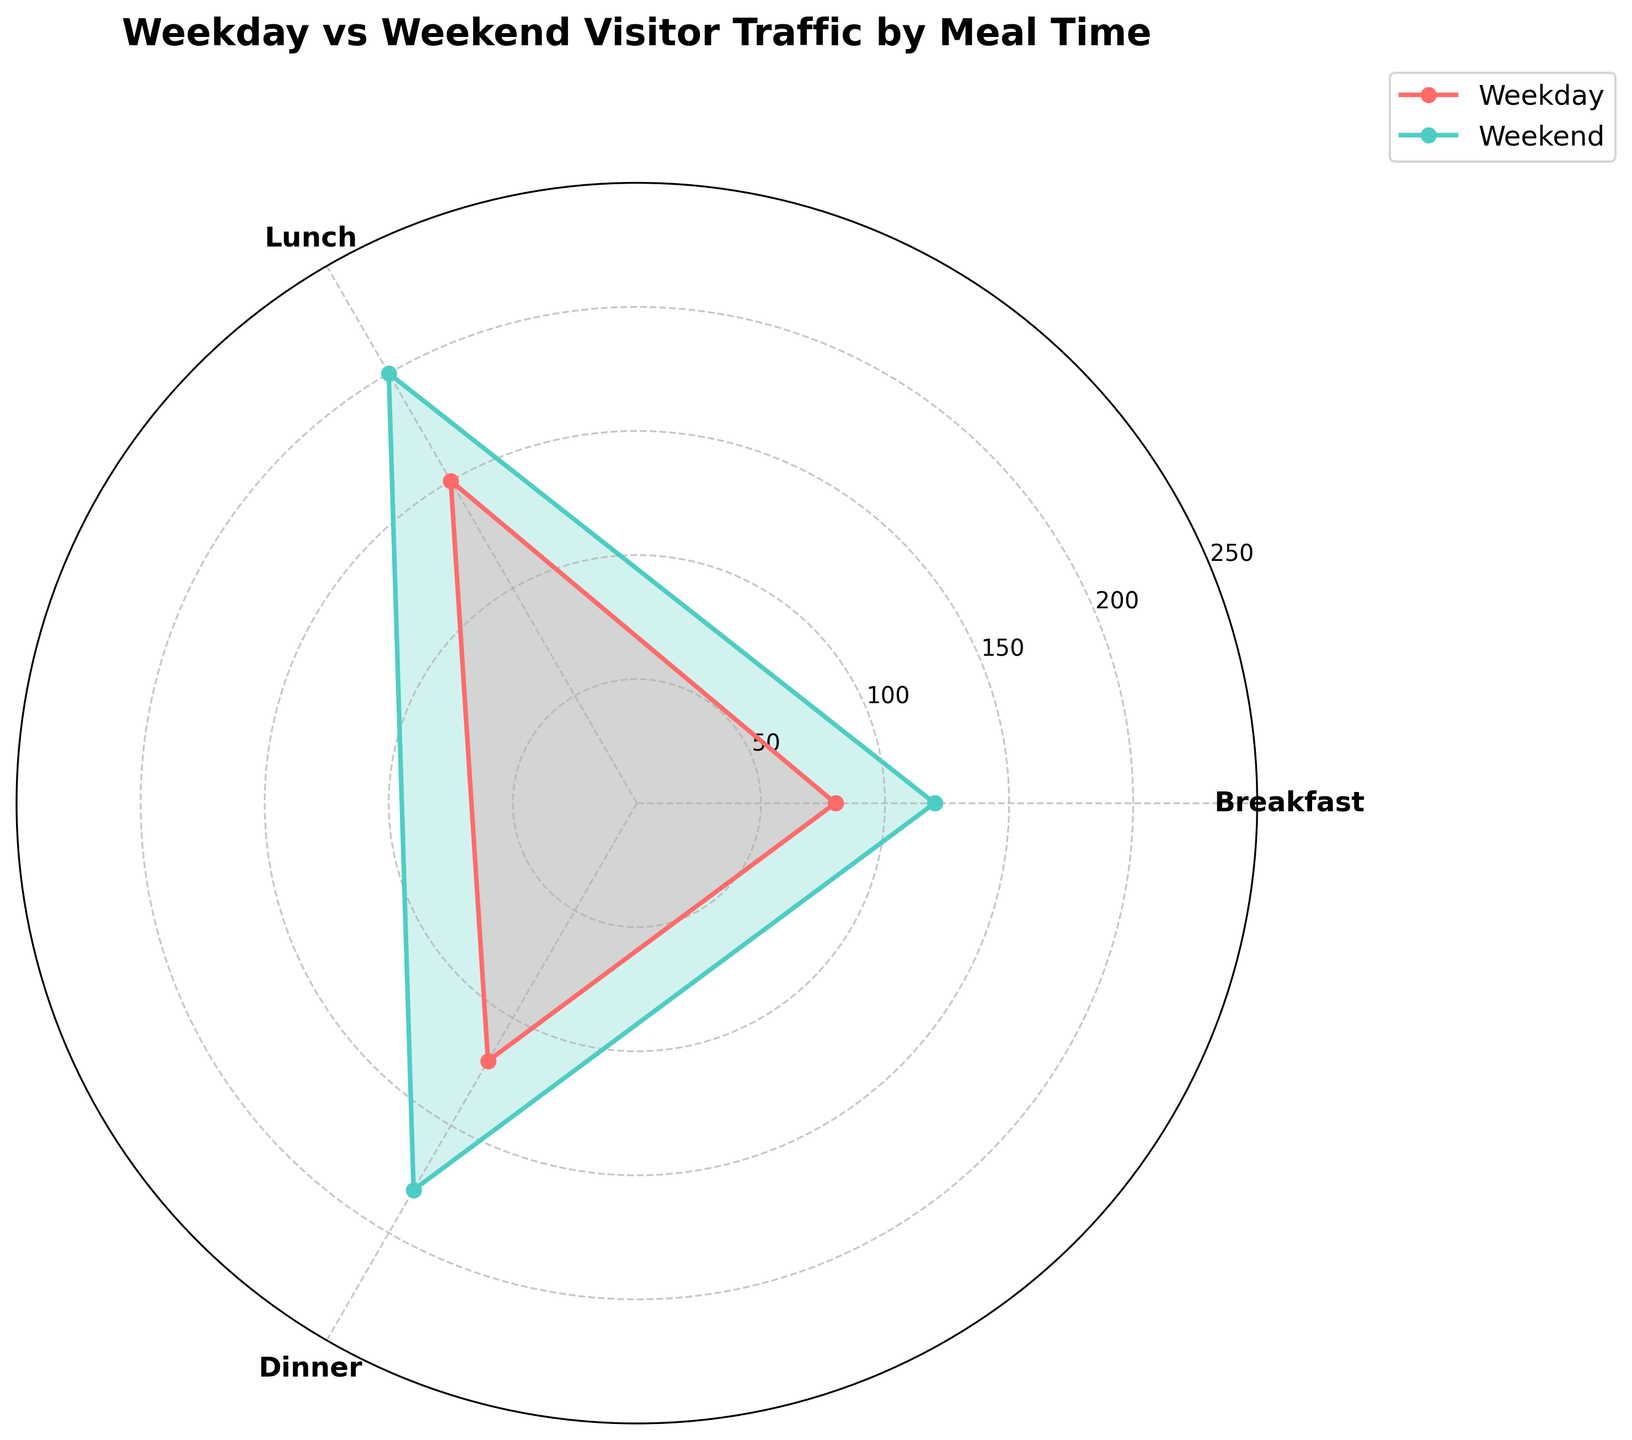What's the title of the figure? The title is displayed at the top of the rose chart in a bold and larger font.
Answer: Weekday vs Weekend Visitor Traffic by Meal Time How many meal times are compared in the figure? The figure labels each segment corresponding to meal times and there are three distinct labels displayed.
Answer: 3 Which day has the higher visitor count during breakfast? By comparing the heights of the segments (spikes) at the label 'Breakfast', we see that the segment for the Weekend is taller than the segment for the Weekday.
Answer: Weekend What is the total visitor count for weekdays? The visitor counts for weekdays during breakfast, lunch, and dinner are 80, 150, and 120 respectively. Summing these values: 80 + 150 + 120 = 350.
Answer: 350 Compare the visitor counts for lunch on weekdays and weekends. By looking at the relative heights of the segments labeled 'Lunch', we see that both the height and area are larger for the Weekend compared to the Weekday. Specifically, weekday lunch has 150 visitors, while weekend lunch has 200 visitors, with 200 being greater than 150.
Answer: Weekend What is the average visitor count during dinner for both weekday and weekend? To find the average, sum the visitor counts for dinner on both days and divide by 2: (120 + 180) / 2 = 300 / 2 = 150.
Answer: 150 During which meal time is the visitor count increase the most from weekdays to weekends? By comparing the increments from weekday to weekend for each meal time: Breakfast (120-80=40), Lunch (200-150=50), and Dinner (180-120=60), we see that Dinner increases the most.
Answer: Dinner Which day has the greater variability in visitor counts across meal times? Variability is determined by difference in visitor counts. For weekdays: max(150, 120, 80) - min(150, 120, 80) = 70; for weekends: max(200, 180, 120) - min(200, 180, 120) = 80. Weekend has greater variability.
Answer: Weekend How does the visitor count for lunch on weekdays compare to dinner on weekends? By looking at the figure, weekday lunch has 150 visitors, whereas weekend dinner has 180 visitors. Since 180 is greater than 150, weekend dinner has a higher count.
Answer: Weekend Dinner Is the visitor traffic more balanced across meal times on weekdays or weekends? Balance can be inferred from the relative consistency of the heights of the segments. Weekday segments (80, 150, 120) have a larger spread compared to weekend segments (120, 200, 180). Thus, visitor traffic on weekends is more balanced.
Answer: Weekend 